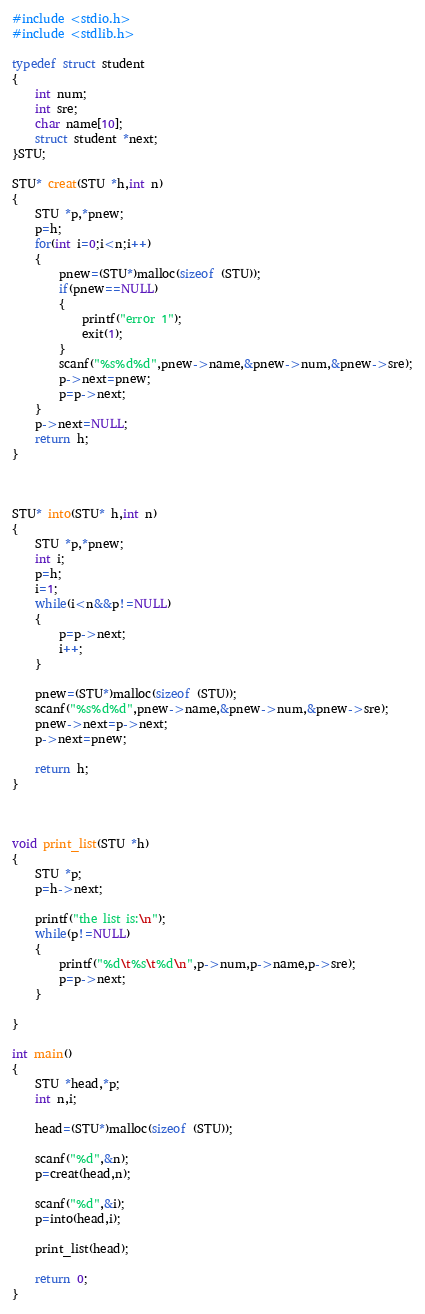<code> <loc_0><loc_0><loc_500><loc_500><_C++_>#include <stdio.h>
#include <stdlib.h>

typedef struct student
{
    int num;
    int sre;
    char name[10];
    struct student *next;
}STU;

STU* creat(STU *h,int n)
{
    STU *p,*pnew;
    p=h;
    for(int i=0;i<n;i++)
    {
        pnew=(STU*)malloc(sizeof (STU));
        if(pnew==NULL)
        {
            printf("error 1");
            exit(1);
        }
        scanf("%s%d%d",pnew->name,&pnew->num,&pnew->sre);
        p->next=pnew;
        p=p->next;
    }
    p->next=NULL;
    return h;
}



STU* into(STU* h,int n)
{
    STU *p,*pnew;
    int i;
    p=h;
    i=1;
    while(i<n&&p!=NULL)
    {
        p=p->next;
        i++;
    }

    pnew=(STU*)malloc(sizeof (STU));
    scanf("%s%d%d",pnew->name,&pnew->num,&pnew->sre);
    pnew->next=p->next;
    p->next=pnew;

    return h;
}



void print_list(STU *h)
{
    STU *p;
    p=h->next;

    printf("the list is:\n");
    while(p!=NULL)
    {
        printf("%d\t%s\t%d\n",p->num,p->name,p->sre);
        p=p->next;
    }

}

int main()
{
    STU *head,*p;
    int n,i;

    head=(STU*)malloc(sizeof (STU));

    scanf("%d",&n);
    p=creat(head,n);

    scanf("%d",&i);
    p=into(head,i);

    print_list(head);

    return 0;
}
</code> 